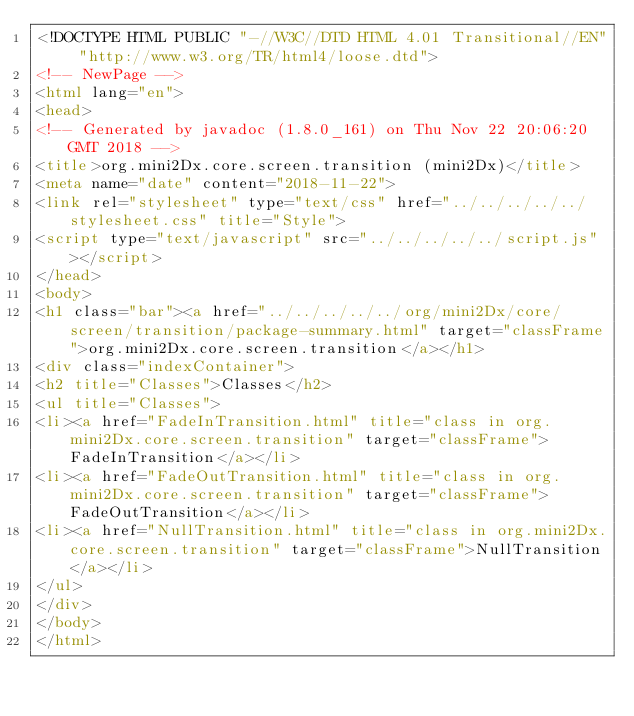<code> <loc_0><loc_0><loc_500><loc_500><_HTML_><!DOCTYPE HTML PUBLIC "-//W3C//DTD HTML 4.01 Transitional//EN" "http://www.w3.org/TR/html4/loose.dtd">
<!-- NewPage -->
<html lang="en">
<head>
<!-- Generated by javadoc (1.8.0_161) on Thu Nov 22 20:06:20 GMT 2018 -->
<title>org.mini2Dx.core.screen.transition (mini2Dx)</title>
<meta name="date" content="2018-11-22">
<link rel="stylesheet" type="text/css" href="../../../../../stylesheet.css" title="Style">
<script type="text/javascript" src="../../../../../script.js"></script>
</head>
<body>
<h1 class="bar"><a href="../../../../../org/mini2Dx/core/screen/transition/package-summary.html" target="classFrame">org.mini2Dx.core.screen.transition</a></h1>
<div class="indexContainer">
<h2 title="Classes">Classes</h2>
<ul title="Classes">
<li><a href="FadeInTransition.html" title="class in org.mini2Dx.core.screen.transition" target="classFrame">FadeInTransition</a></li>
<li><a href="FadeOutTransition.html" title="class in org.mini2Dx.core.screen.transition" target="classFrame">FadeOutTransition</a></li>
<li><a href="NullTransition.html" title="class in org.mini2Dx.core.screen.transition" target="classFrame">NullTransition</a></li>
</ul>
</div>
</body>
</html>
</code> 